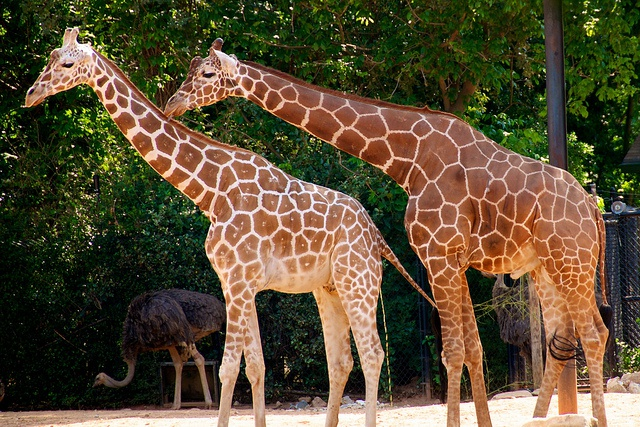Describe the objects in this image and their specific colors. I can see giraffe in black, brown, and tan tones, giraffe in black, brown, tan, and lightgray tones, and bird in black, maroon, and gray tones in this image. 